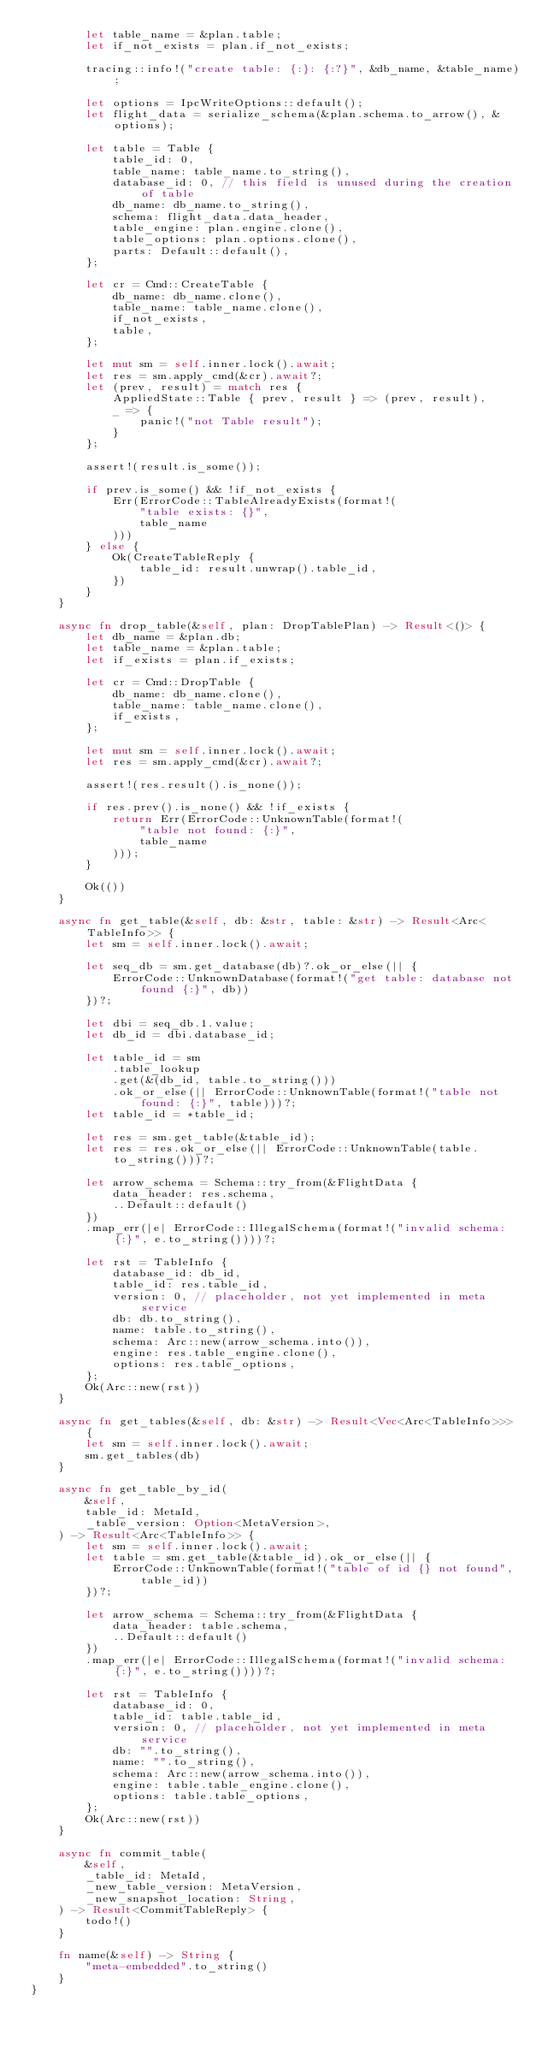<code> <loc_0><loc_0><loc_500><loc_500><_Rust_>        let table_name = &plan.table;
        let if_not_exists = plan.if_not_exists;

        tracing::info!("create table: {:}: {:?}", &db_name, &table_name);

        let options = IpcWriteOptions::default();
        let flight_data = serialize_schema(&plan.schema.to_arrow(), &options);

        let table = Table {
            table_id: 0,
            table_name: table_name.to_string(),
            database_id: 0, // this field is unused during the creation of table
            db_name: db_name.to_string(),
            schema: flight_data.data_header,
            table_engine: plan.engine.clone(),
            table_options: plan.options.clone(),
            parts: Default::default(),
        };

        let cr = Cmd::CreateTable {
            db_name: db_name.clone(),
            table_name: table_name.clone(),
            if_not_exists,
            table,
        };

        let mut sm = self.inner.lock().await;
        let res = sm.apply_cmd(&cr).await?;
        let (prev, result) = match res {
            AppliedState::Table { prev, result } => (prev, result),
            _ => {
                panic!("not Table result");
            }
        };

        assert!(result.is_some());

        if prev.is_some() && !if_not_exists {
            Err(ErrorCode::TableAlreadyExists(format!(
                "table exists: {}",
                table_name
            )))
        } else {
            Ok(CreateTableReply {
                table_id: result.unwrap().table_id,
            })
        }
    }

    async fn drop_table(&self, plan: DropTablePlan) -> Result<()> {
        let db_name = &plan.db;
        let table_name = &plan.table;
        let if_exists = plan.if_exists;

        let cr = Cmd::DropTable {
            db_name: db_name.clone(),
            table_name: table_name.clone(),
            if_exists,
        };

        let mut sm = self.inner.lock().await;
        let res = sm.apply_cmd(&cr).await?;

        assert!(res.result().is_none());

        if res.prev().is_none() && !if_exists {
            return Err(ErrorCode::UnknownTable(format!(
                "table not found: {:}",
                table_name
            )));
        }

        Ok(())
    }

    async fn get_table(&self, db: &str, table: &str) -> Result<Arc<TableInfo>> {
        let sm = self.inner.lock().await;

        let seq_db = sm.get_database(db)?.ok_or_else(|| {
            ErrorCode::UnknownDatabase(format!("get table: database not found {:}", db))
        })?;

        let dbi = seq_db.1.value;
        let db_id = dbi.database_id;

        let table_id = sm
            .table_lookup
            .get(&(db_id, table.to_string()))
            .ok_or_else(|| ErrorCode::UnknownTable(format!("table not found: {:}", table)))?;
        let table_id = *table_id;

        let res = sm.get_table(&table_id);
        let res = res.ok_or_else(|| ErrorCode::UnknownTable(table.to_string()))?;

        let arrow_schema = Schema::try_from(&FlightData {
            data_header: res.schema,
            ..Default::default()
        })
        .map_err(|e| ErrorCode::IllegalSchema(format!("invalid schema: {:}", e.to_string())))?;

        let rst = TableInfo {
            database_id: db_id,
            table_id: res.table_id,
            version: 0, // placeholder, not yet implemented in meta service
            db: db.to_string(),
            name: table.to_string(),
            schema: Arc::new(arrow_schema.into()),
            engine: res.table_engine.clone(),
            options: res.table_options,
        };
        Ok(Arc::new(rst))
    }

    async fn get_tables(&self, db: &str) -> Result<Vec<Arc<TableInfo>>> {
        let sm = self.inner.lock().await;
        sm.get_tables(db)
    }

    async fn get_table_by_id(
        &self,
        table_id: MetaId,
        _table_version: Option<MetaVersion>,
    ) -> Result<Arc<TableInfo>> {
        let sm = self.inner.lock().await;
        let table = sm.get_table(&table_id).ok_or_else(|| {
            ErrorCode::UnknownTable(format!("table of id {} not found", table_id))
        })?;

        let arrow_schema = Schema::try_from(&FlightData {
            data_header: table.schema,
            ..Default::default()
        })
        .map_err(|e| ErrorCode::IllegalSchema(format!("invalid schema: {:}", e.to_string())))?;

        let rst = TableInfo {
            database_id: 0,
            table_id: table.table_id,
            version: 0, // placeholder, not yet implemented in meta service
            db: "".to_string(),
            name: "".to_string(),
            schema: Arc::new(arrow_schema.into()),
            engine: table.table_engine.clone(),
            options: table.table_options,
        };
        Ok(Arc::new(rst))
    }

    async fn commit_table(
        &self,
        _table_id: MetaId,
        _new_table_version: MetaVersion,
        _new_snapshot_location: String,
    ) -> Result<CommitTableReply> {
        todo!()
    }

    fn name(&self) -> String {
        "meta-embedded".to_string()
    }
}
</code> 